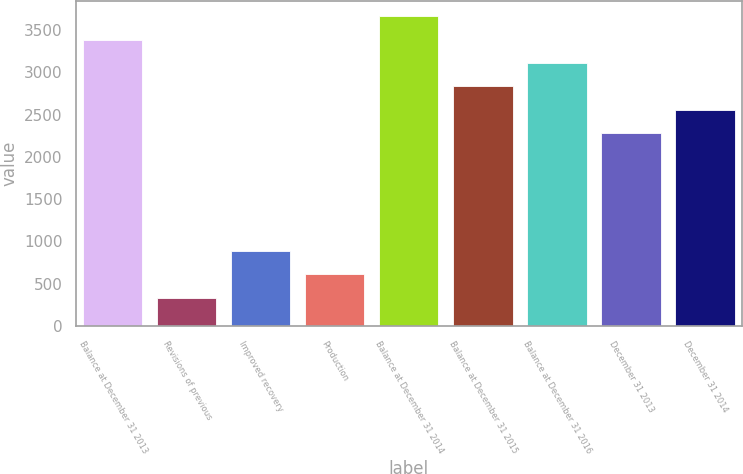<chart> <loc_0><loc_0><loc_500><loc_500><bar_chart><fcel>Balance at December 31 2013<fcel>Revisions of previous<fcel>Improved recovery<fcel>Production<fcel>Balance at December 31 2014<fcel>Balance at December 31 2015<fcel>Balance at December 31 2016<fcel>December 31 2013<fcel>December 31 2014<nl><fcel>3388.6<fcel>334.1<fcel>886.3<fcel>610.2<fcel>3664.7<fcel>2836.4<fcel>3112.5<fcel>2284.2<fcel>2560.3<nl></chart> 